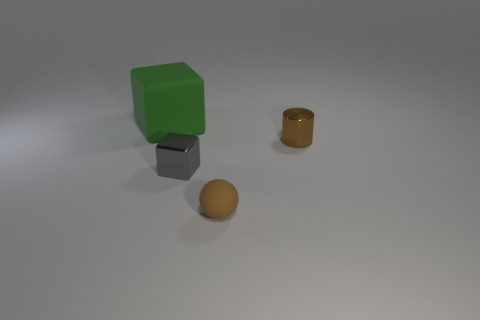Does the brown object behind the brown matte sphere have the same size as the green block?
Offer a terse response. No. What number of metal objects are blocks or tiny red cylinders?
Keep it short and to the point. 1. What is the material of the tiny object that is behind the rubber sphere and left of the brown cylinder?
Your answer should be compact. Metal. Are the green block and the gray block made of the same material?
Your answer should be very brief. No. How big is the thing that is both behind the tiny ball and right of the gray metal cube?
Your answer should be very brief. Small. The brown metal object has what shape?
Provide a short and direct response. Cylinder. What number of objects are big red cubes or objects behind the rubber sphere?
Your response must be concise. 3. There is a matte object behind the brown cylinder; is its color the same as the tiny cylinder?
Offer a very short reply. No. What color is the small thing that is behind the small brown rubber object and left of the tiny metal cylinder?
Keep it short and to the point. Gray. There is a cube right of the large matte cube; what material is it?
Offer a very short reply. Metal. 